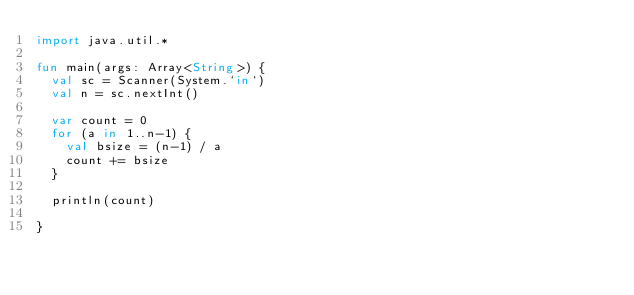Convert code to text. <code><loc_0><loc_0><loc_500><loc_500><_Kotlin_>import java.util.*

fun main(args: Array<String>) {
  val sc = Scanner(System.`in`)
  val n = sc.nextInt()

  var count = 0
  for (a in 1..n-1) {
    val bsize = (n-1) / a
    count += bsize
  }

  println(count)

}
</code> 